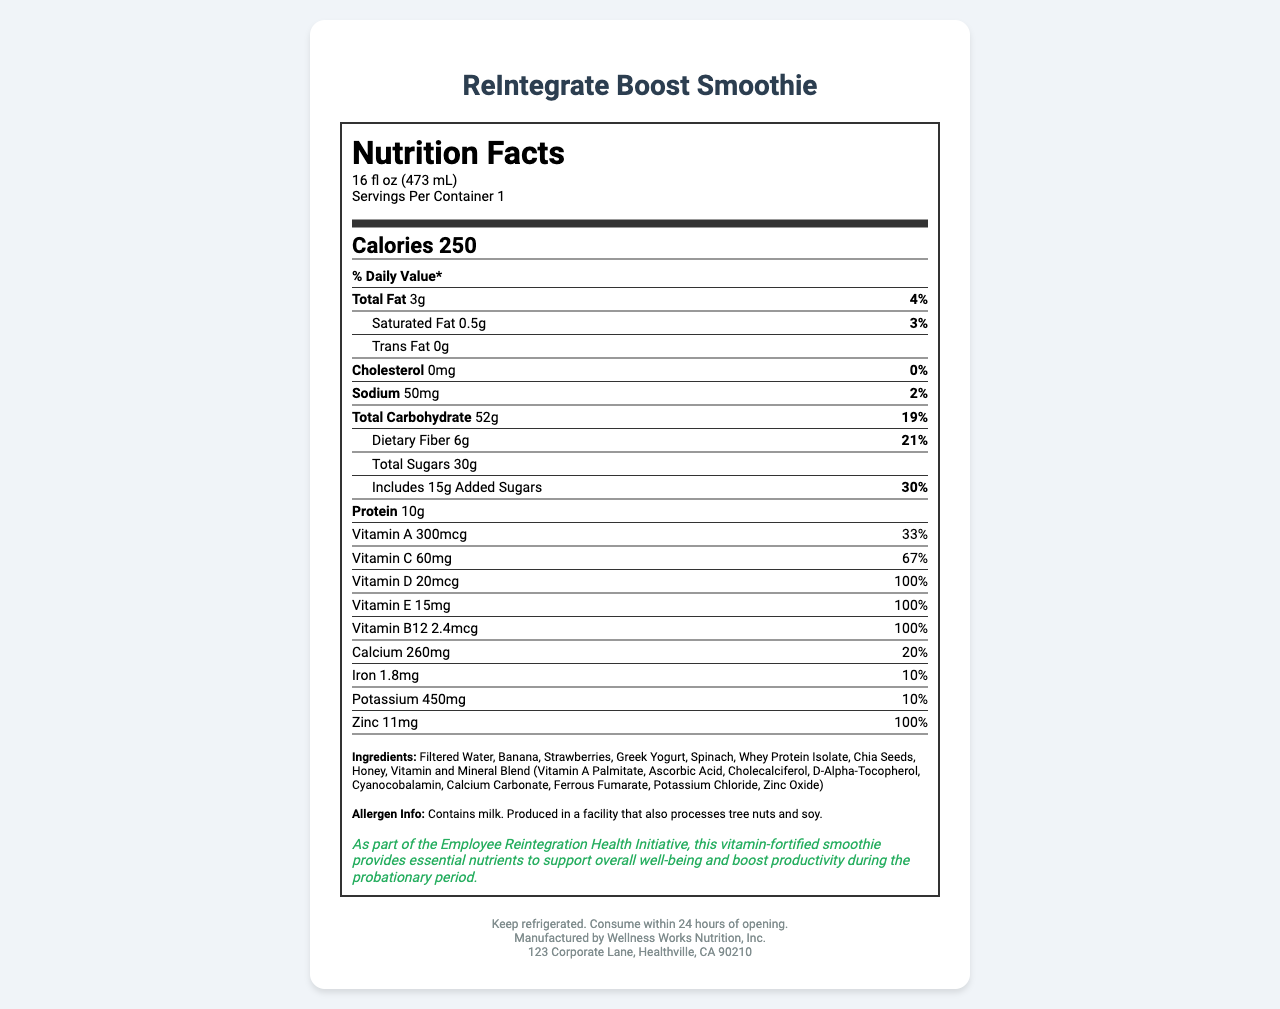what is the serving size of the ReIntegrate Boost Smoothie? The serving size is clearly mentioned at the top of the nutrition facts section.
Answer: 16 fl oz (473 mL) How many calories are there per serving? The calories per serving are listed prominently under the nutrition title in bold.
Answer: 250 calories What percentage of the daily value of dietary fiber does one serving provide? The daily value percentage of dietary fiber is listed alongside its amount on the nutrition facts label.
Answer: 21% How much total fat does the smoothie contain? The total fat content is provided under the section labeled "Total Fat".
Answer: 3g Does this smoothie contain any trans fat? The label clearly states that the trans fat content is 0g.
Answer: No what is the daily value percentage for Vitamin C? A. 30% B. 67% C. 100% D. 25% The daily value percentage for Vitamin C is listed as 67% on the nutrition facts label.
Answer: B How much added sugar does one serving of the smoothie have? a) 10g b) 15g c) 20g d) 25g The amount of added sugars is mentioned under the "Total Carbohydrate" section.
Answer: b) 15g Does this product contain any milk? The allergen info section explicitly states that the product contains milk.
Answer: Yes Is the smoothie a good source of protein? The smoothie contains 10g of protein, which is relatively high for a serving size of 16 fl oz.
Answer: Yes Summarize the main purpose of the ReIntegrate Boost Smoothie as described in the health claim. The health claim section mentions that the smoothie is part of the Employee Reintegration Health Initiative and aims to support employees during their probationary period by providing essential nutrients.
Answer: The ReIntegrate Boost Smoothie is intended to provide essential nutrients that support overall well-being and boost productivity during the employee reintegration process. What is the address of the manufacturer? The address of the manufacturer, Wellness Works Nutrition, Inc., is stated at the bottom of the document.
Answer: 123 Corporate Lane, Healthville, CA 90210 What is the percentage value of iron provided by one serving of the smoothie? The daily value percentage of iron is listed in the nutrition facts section as 10%.
Answer: 10% Which vitamin provides 100% of the daily value per serving in this product? a) Vitamin A b) Vitamin C c) Vitamin E d) Vitamin B12 Vitamin B12 provides 100% of the daily value per serving as clearly marked on the nutrition facts label.
Answer: d) Vitamin B12 Can you determine if the smoothie is gluten-free? The label does not provide any details about the gluten content or certification.
Answer: Not enough information 